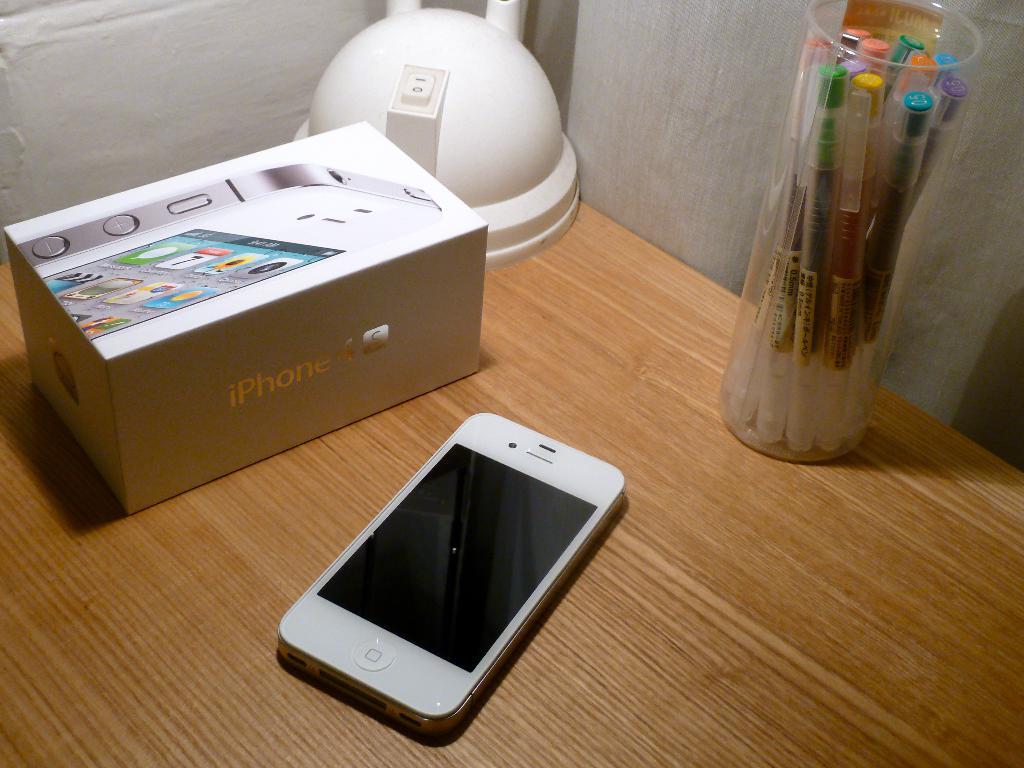What model name is written on the side of the box?
Your answer should be compact. Iphone 4s. 